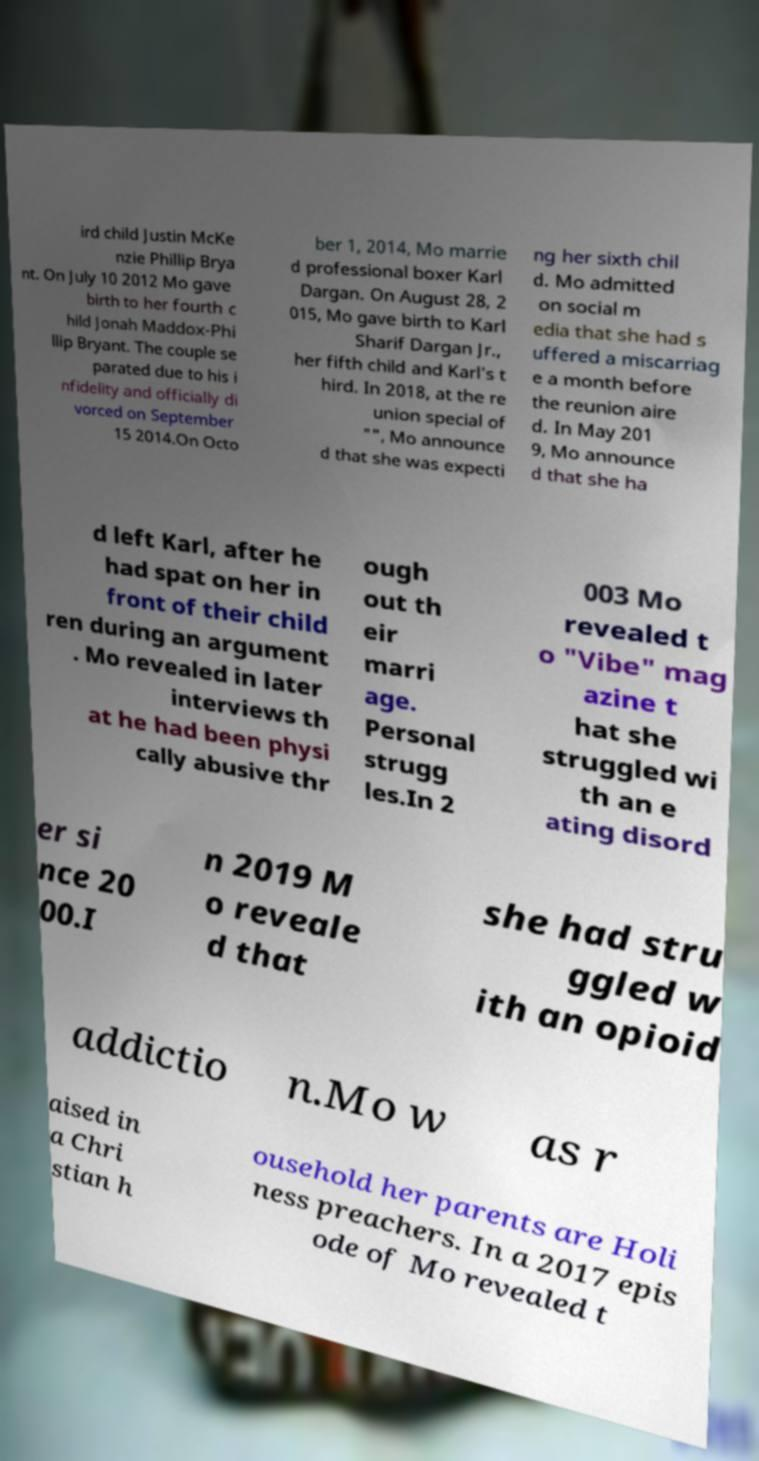Can you read and provide the text displayed in the image?This photo seems to have some interesting text. Can you extract and type it out for me? ird child Justin McKe nzie Phillip Brya nt. On July 10 2012 Mo gave birth to her fourth c hild Jonah Maddox-Phi llip Bryant. The couple se parated due to his i nfidelity and officially di vorced on September 15 2014.On Octo ber 1, 2014, Mo marrie d professional boxer Karl Dargan. On August 28, 2 015, Mo gave birth to Karl Sharif Dargan Jr., her fifth child and Karl's t hird. In 2018, at the re union special of "", Mo announce d that she was expecti ng her sixth chil d. Mo admitted on social m edia that she had s uffered a miscarriag e a month before the reunion aire d. In May 201 9, Mo announce d that she ha d left Karl, after he had spat on her in front of their child ren during an argument . Mo revealed in later interviews th at he had been physi cally abusive thr ough out th eir marri age. Personal strugg les.In 2 003 Mo revealed t o "Vibe" mag azine t hat she struggled wi th an e ating disord er si nce 20 00.I n 2019 M o reveale d that she had stru ggled w ith an opioid addictio n.Mo w as r aised in a Chri stian h ousehold her parents are Holi ness preachers. In a 2017 epis ode of Mo revealed t 